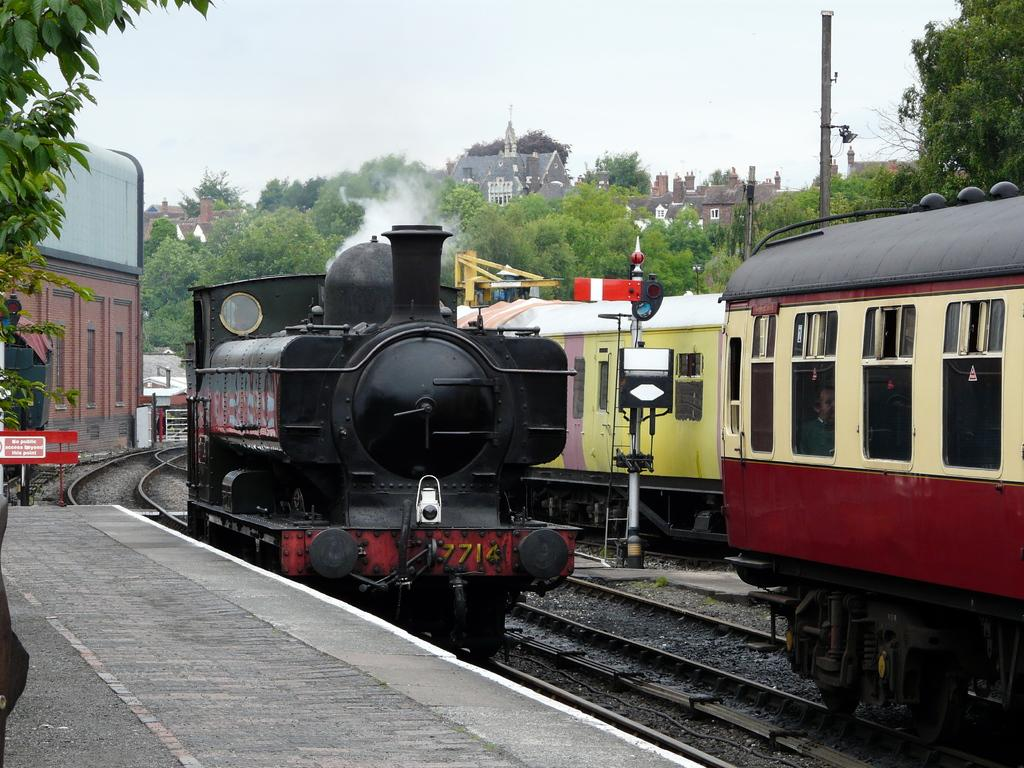What type of vehicles can be seen on the tracks in the image? There are trains on the tracks in the image. What structure is present near the tracks? There is a platform in the image. What device is used to control train movement in the image? A signal indicator is present in the image. What type of information might be conveyed by the sign boards in the image? The sign boards in the image might convey information about train schedules, routes, or safety instructions. What type of structures are visible in the image? There are buildings in the image. What type of vegetation can be seen in the image? Trees are visible in the image. What type of vertical structures are present in the image? Poles are present in the image. What part of the natural environment is visible in the image? The sky is visible in the image. Where are the ants crawling on the train in the image? There are no ants present in the image. What type of beast is roaming around the platform in the image? There are no beasts present in the image. 